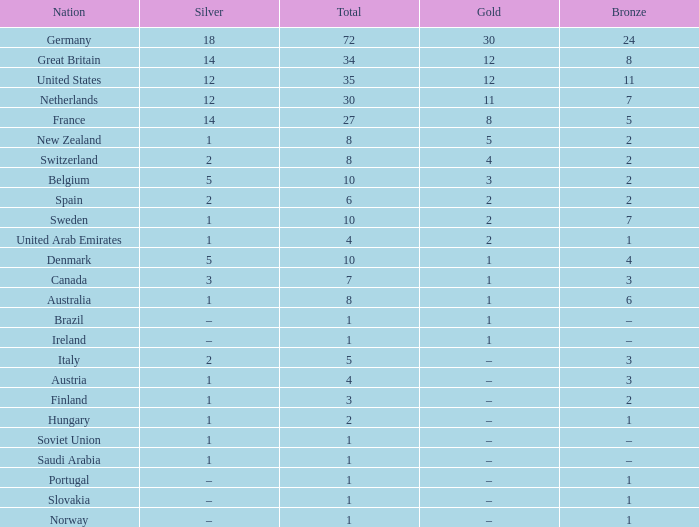What is Gold, when Silver is 5, and when Nation is Belgium? 3.0. 